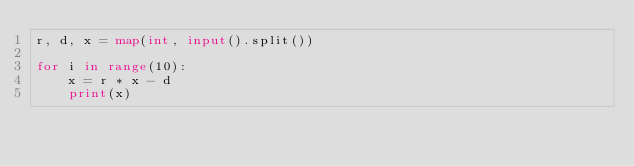<code> <loc_0><loc_0><loc_500><loc_500><_Python_>r, d, x = map(int, input().split())

for i in range(10):
    x = r * x - d
    print(x)
</code> 